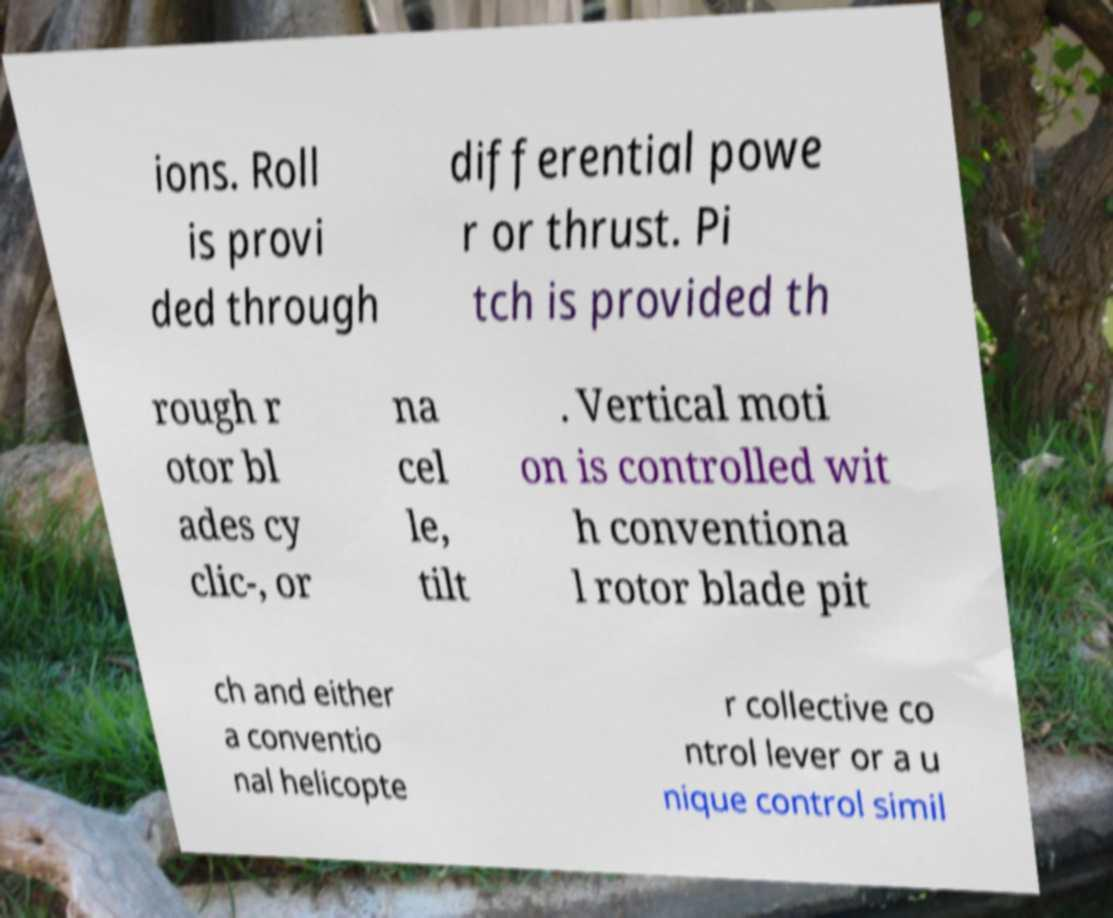There's text embedded in this image that I need extracted. Can you transcribe it verbatim? ions. Roll is provi ded through differential powe r or thrust. Pi tch is provided th rough r otor bl ades cy clic-, or na cel le, tilt . Vertical moti on is controlled wit h conventiona l rotor blade pit ch and either a conventio nal helicopte r collective co ntrol lever or a u nique control simil 